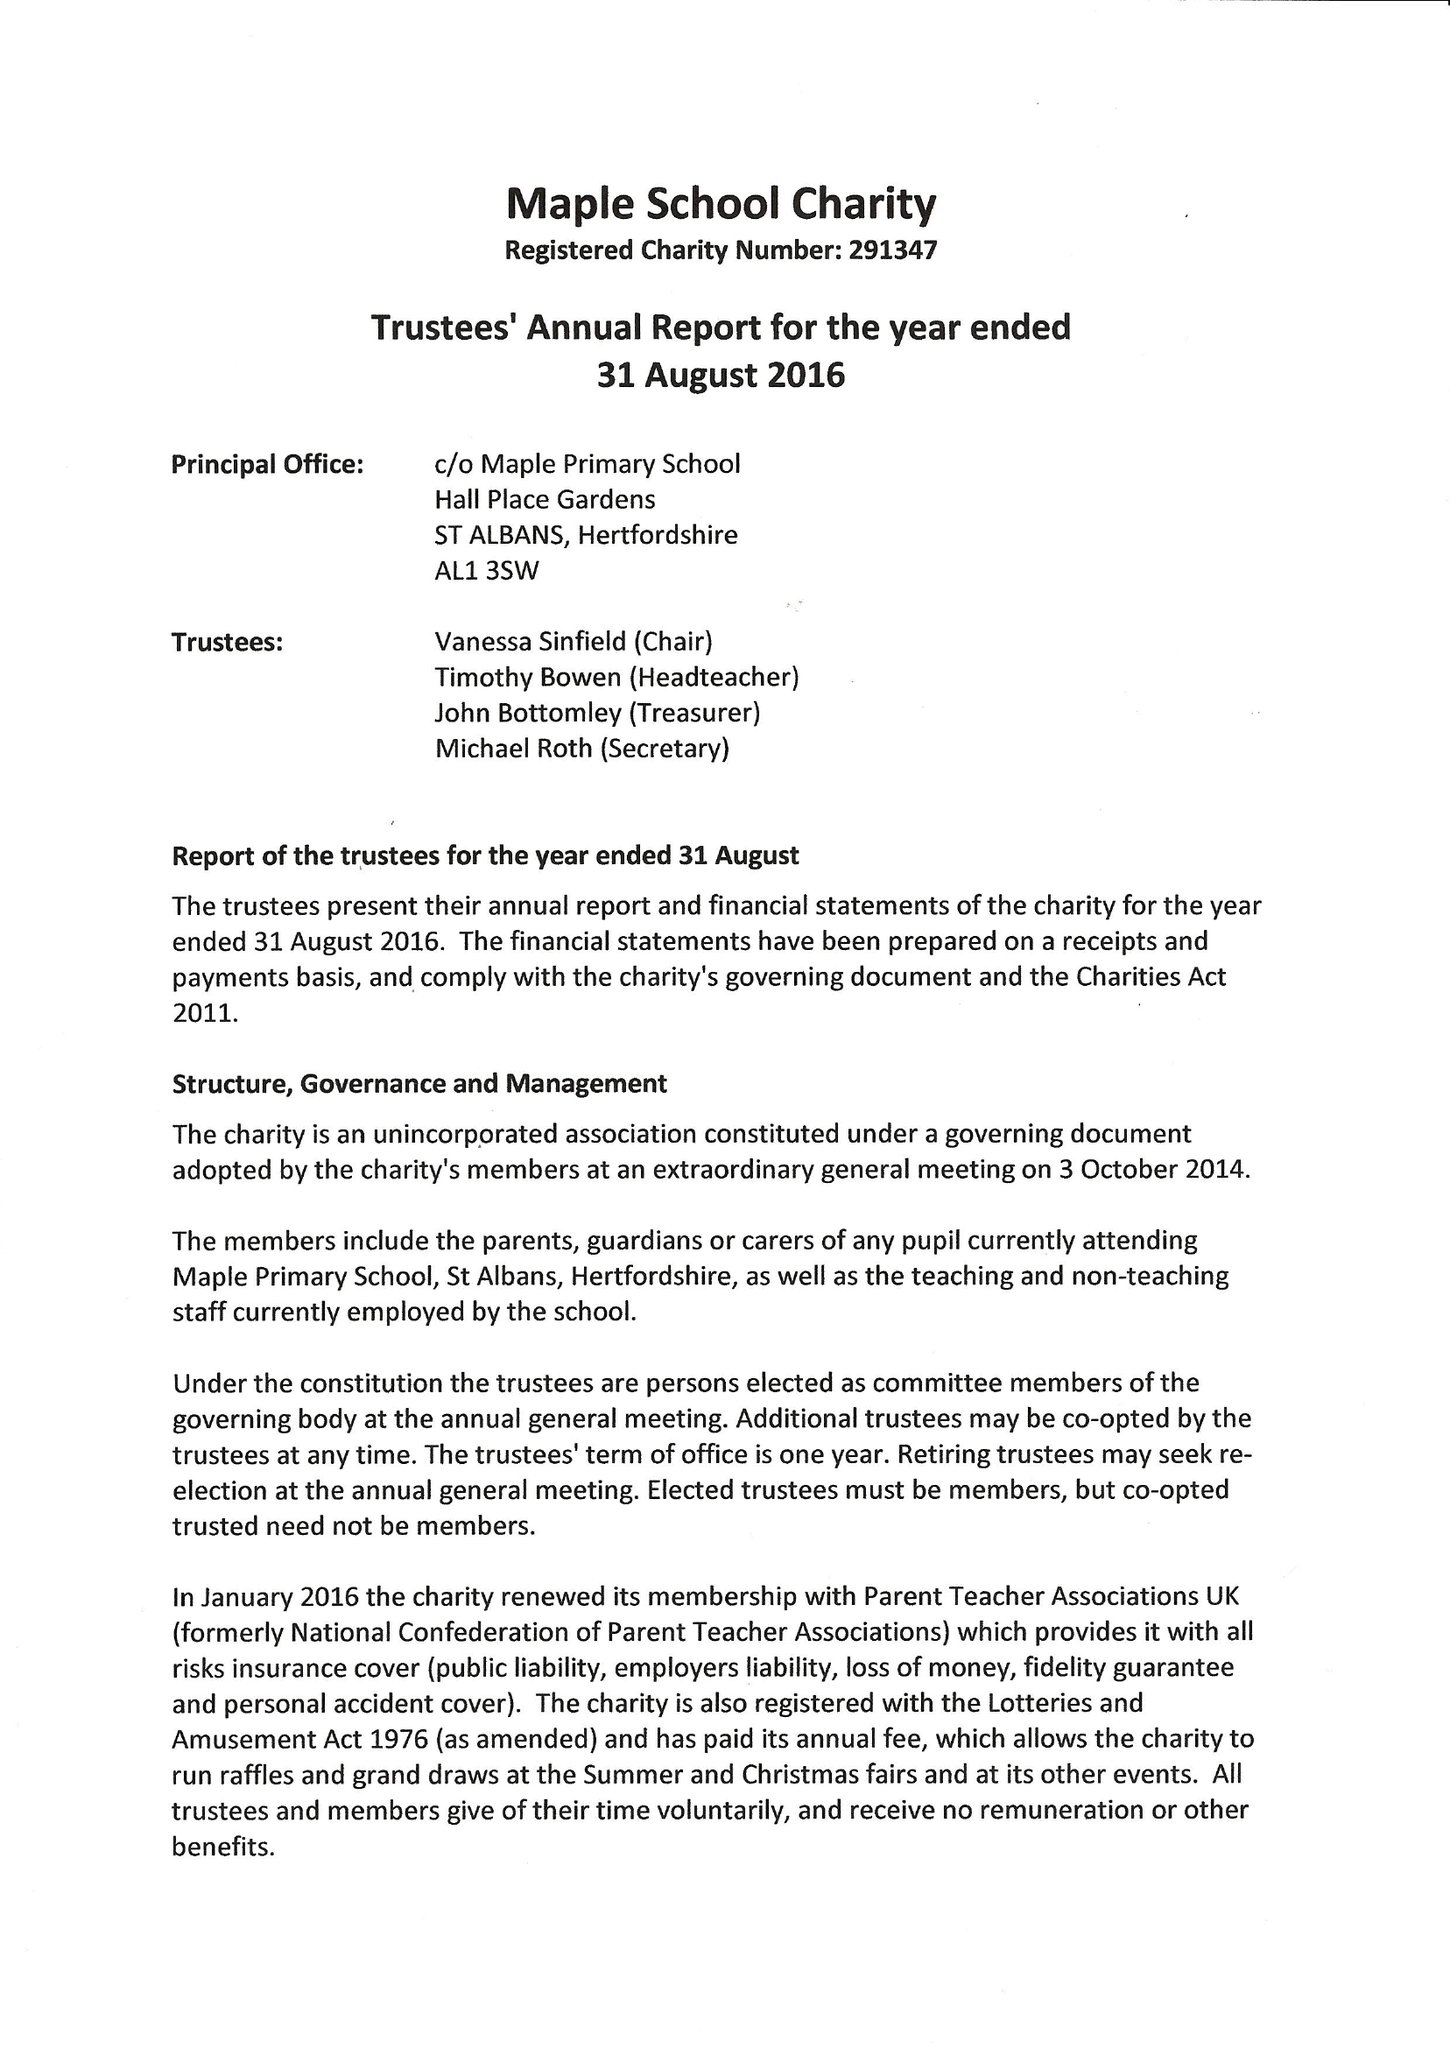What is the value for the address__postcode?
Answer the question using a single word or phrase. AL1 3SW 